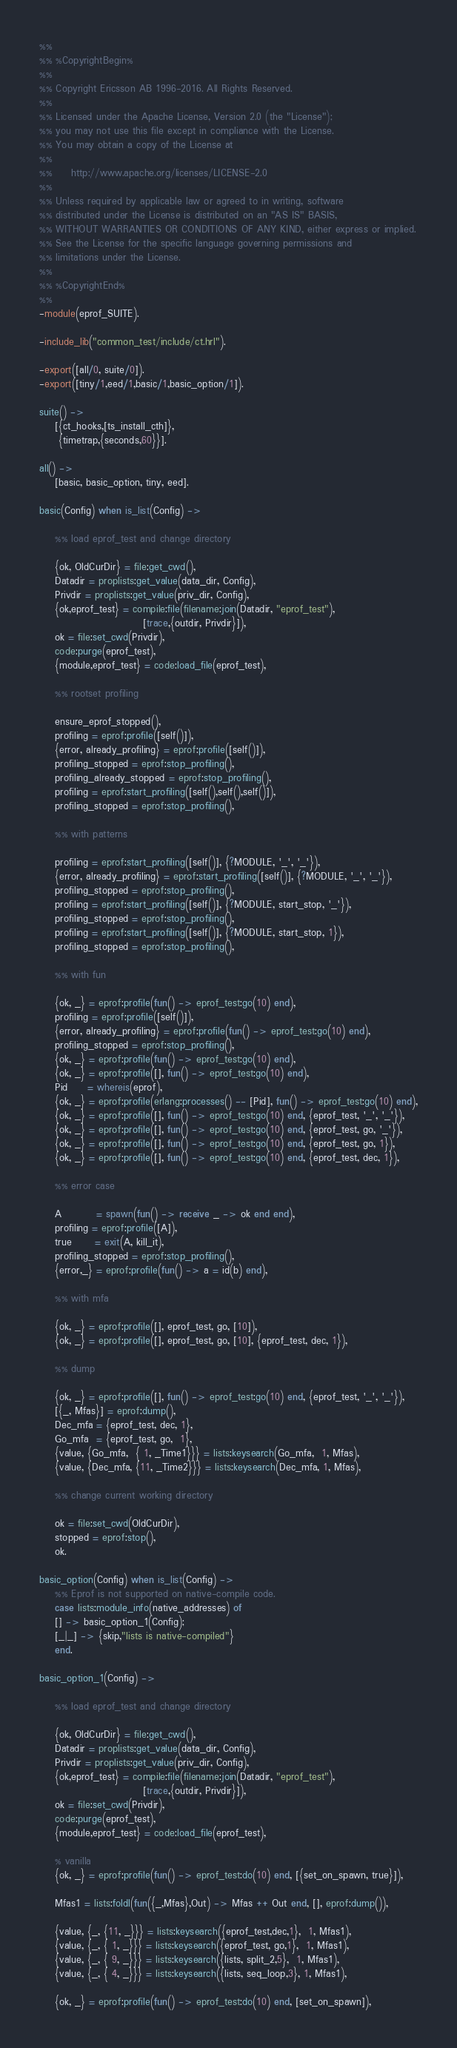<code> <loc_0><loc_0><loc_500><loc_500><_Erlang_>%%
%% %CopyrightBegin%
%%
%% Copyright Ericsson AB 1996-2016. All Rights Reserved.
%%
%% Licensed under the Apache License, Version 2.0 (the "License");
%% you may not use this file except in compliance with the License.
%% You may obtain a copy of the License at
%%
%%     http://www.apache.org/licenses/LICENSE-2.0
%%
%% Unless required by applicable law or agreed to in writing, software
%% distributed under the License is distributed on an "AS IS" BASIS,
%% WITHOUT WARRANTIES OR CONDITIONS OF ANY KIND, either express or implied.
%% See the License for the specific language governing permissions and
%% limitations under the License.
%%
%% %CopyrightEnd%
%%
-module(eprof_SUITE).

-include_lib("common_test/include/ct.hrl").

-export([all/0, suite/0]).
-export([tiny/1,eed/1,basic/1,basic_option/1]).

suite() ->
    [{ct_hooks,[ts_install_cth]},
     {timetrap,{seconds,60}}].

all() -> 
    [basic, basic_option, tiny, eed].

basic(Config) when is_list(Config) ->

    %% load eprof_test and change directory

    {ok, OldCurDir} = file:get_cwd(),
    Datadir = proplists:get_value(data_dir, Config),
    Privdir = proplists:get_value(priv_dir, Config),
    {ok,eprof_test} = compile:file(filename:join(Datadir, "eprof_test"),
					       [trace,{outdir, Privdir}]),
    ok = file:set_cwd(Privdir),
    code:purge(eprof_test),
    {module,eprof_test} = code:load_file(eprof_test),

    %% rootset profiling

    ensure_eprof_stopped(),
    profiling = eprof:profile([self()]),
    {error, already_profiling} = eprof:profile([self()]),
    profiling_stopped = eprof:stop_profiling(),
    profiling_already_stopped = eprof:stop_profiling(),
    profiling = eprof:start_profiling([self(),self(),self()]),
    profiling_stopped = eprof:stop_profiling(),

    %% with patterns

    profiling = eprof:start_profiling([self()], {?MODULE, '_', '_'}),
    {error, already_profiling} = eprof:start_profiling([self()], {?MODULE, '_', '_'}),
    profiling_stopped = eprof:stop_profiling(),
    profiling = eprof:start_profiling([self()], {?MODULE, start_stop, '_'}),
    profiling_stopped = eprof:stop_profiling(),
    profiling = eprof:start_profiling([self()], {?MODULE, start_stop, 1}),
    profiling_stopped = eprof:stop_profiling(),

    %% with fun

    {ok, _} = eprof:profile(fun() -> eprof_test:go(10) end),
    profiling = eprof:profile([self()]),
    {error, already_profiling} = eprof:profile(fun() -> eprof_test:go(10) end),
    profiling_stopped = eprof:stop_profiling(),
    {ok, _} = eprof:profile(fun() -> eprof_test:go(10) end),
    {ok, _} = eprof:profile([], fun() -> eprof_test:go(10) end),
    Pid     = whereis(eprof),
    {ok, _} = eprof:profile(erlang:processes() -- [Pid], fun() -> eprof_test:go(10) end),
    {ok, _} = eprof:profile([], fun() -> eprof_test:go(10) end, {eprof_test, '_', '_'}),
    {ok, _} = eprof:profile([], fun() -> eprof_test:go(10) end, {eprof_test, go, '_'}),
    {ok, _} = eprof:profile([], fun() -> eprof_test:go(10) end, {eprof_test, go, 1}),
    {ok, _} = eprof:profile([], fun() -> eprof_test:go(10) end, {eprof_test, dec, 1}),

    %% error case

    A         = spawn(fun() -> receive _ -> ok end end),
    profiling = eprof:profile([A]),
    true      = exit(A, kill_it),
    profiling_stopped = eprof:stop_profiling(),
    {error,_} = eprof:profile(fun() -> a = id(b) end),

    %% with mfa

    {ok, _} = eprof:profile([], eprof_test, go, [10]),
    {ok, _} = eprof:profile([], eprof_test, go, [10], {eprof_test, dec, 1}),

    %% dump

    {ok, _} = eprof:profile([], fun() -> eprof_test:go(10) end, {eprof_test, '_', '_'}),
    [{_, Mfas}] = eprof:dump(),
    Dec_mfa = {eprof_test, dec, 1},
    Go_mfa  = {eprof_test, go,  1},
    {value, {Go_mfa,  { 1, _Time1}}} = lists:keysearch(Go_mfa,  1, Mfas),
    {value, {Dec_mfa, {11, _Time2}}} = lists:keysearch(Dec_mfa, 1, Mfas),

    %% change current working directory

    ok = file:set_cwd(OldCurDir),
    stopped = eprof:stop(),
    ok.

basic_option(Config) when is_list(Config) ->
    %% Eprof is not supported on native-compile code.
    case lists:module_info(native_addresses) of
	[] -> basic_option_1(Config);
	[_|_] -> {skip,"lists is native-compiled"}
    end.

basic_option_1(Config) ->

    %% load eprof_test and change directory

    {ok, OldCurDir} = file:get_cwd(),
    Datadir = proplists:get_value(data_dir, Config),
    Privdir = proplists:get_value(priv_dir, Config),
    {ok,eprof_test} = compile:file(filename:join(Datadir, "eprof_test"),
					       [trace,{outdir, Privdir}]),
    ok = file:set_cwd(Privdir),
    code:purge(eprof_test),
    {module,eprof_test} = code:load_file(eprof_test),

    % vanilla
    {ok, _} = eprof:profile(fun() -> eprof_test:do(10) end, [{set_on_spawn, true}]),

    Mfas1 = lists:foldl(fun({_,Mfas},Out) -> Mfas ++ Out end, [], eprof:dump()),

    {value, {_, {11, _}}} = lists:keysearch({eprof_test,dec,1},  1, Mfas1),
    {value, {_, { 1, _}}} = lists:keysearch({eprof_test, go,1},  1, Mfas1),
    {value, {_, { 9, _}}} = lists:keysearch({lists, split_2,5},  1, Mfas1),
    {value, {_, { 4, _}}} = lists:keysearch({lists, seq_loop,3}, 1, Mfas1),

    {ok, _} = eprof:profile(fun() -> eprof_test:do(10) end, [set_on_spawn]),
</code> 